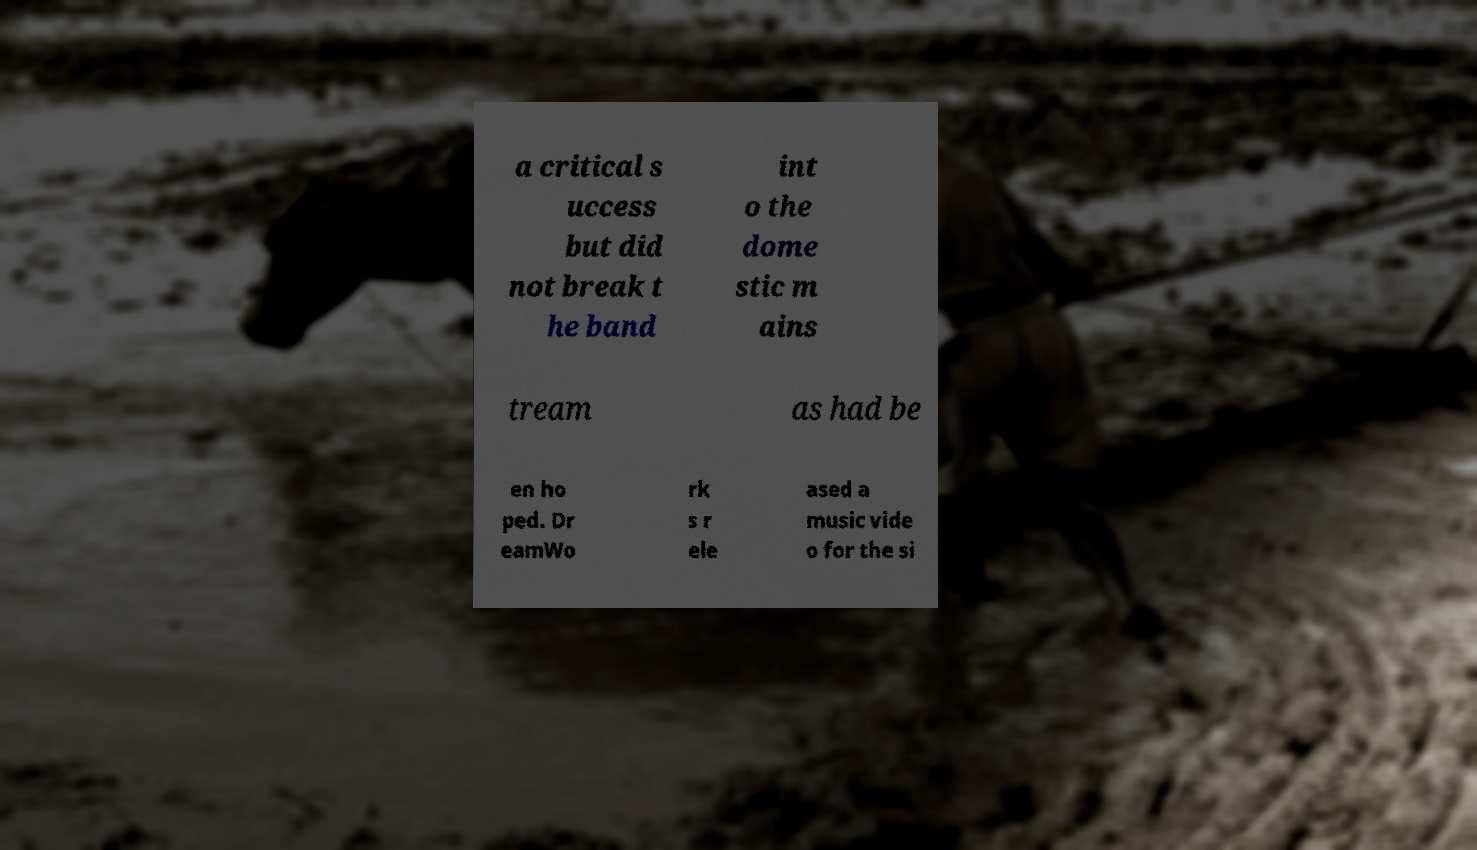Please identify and transcribe the text found in this image. a critical s uccess but did not break t he band int o the dome stic m ains tream as had be en ho ped. Dr eamWo rk s r ele ased a music vide o for the si 